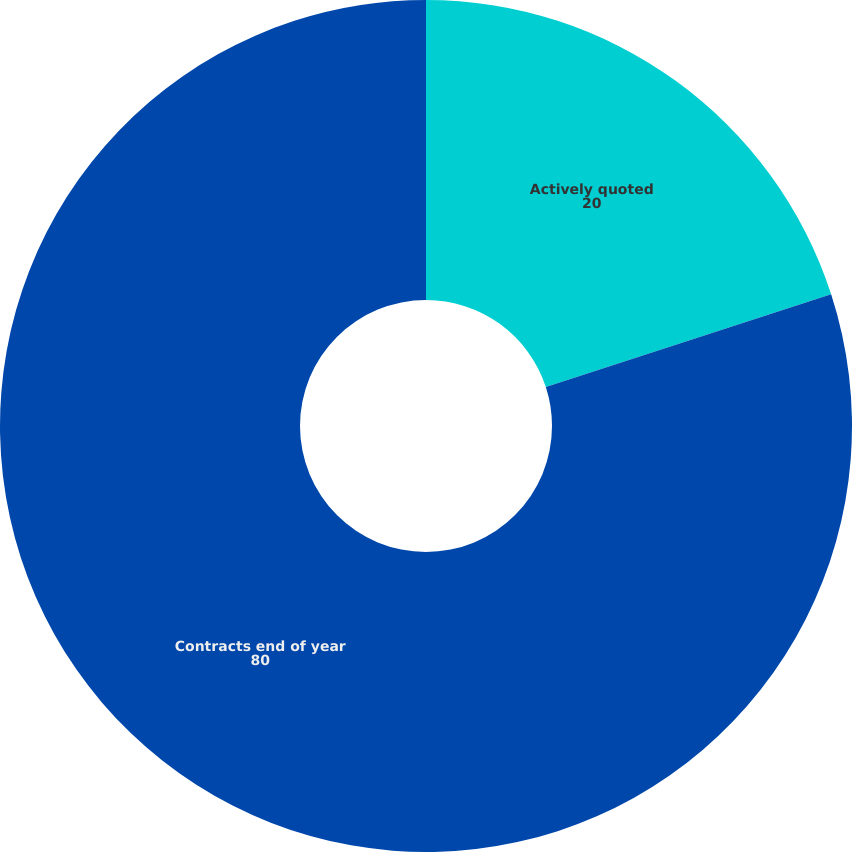Convert chart. <chart><loc_0><loc_0><loc_500><loc_500><pie_chart><fcel>Actively quoted<fcel>Contracts end of year<nl><fcel>20.0%<fcel>80.0%<nl></chart> 